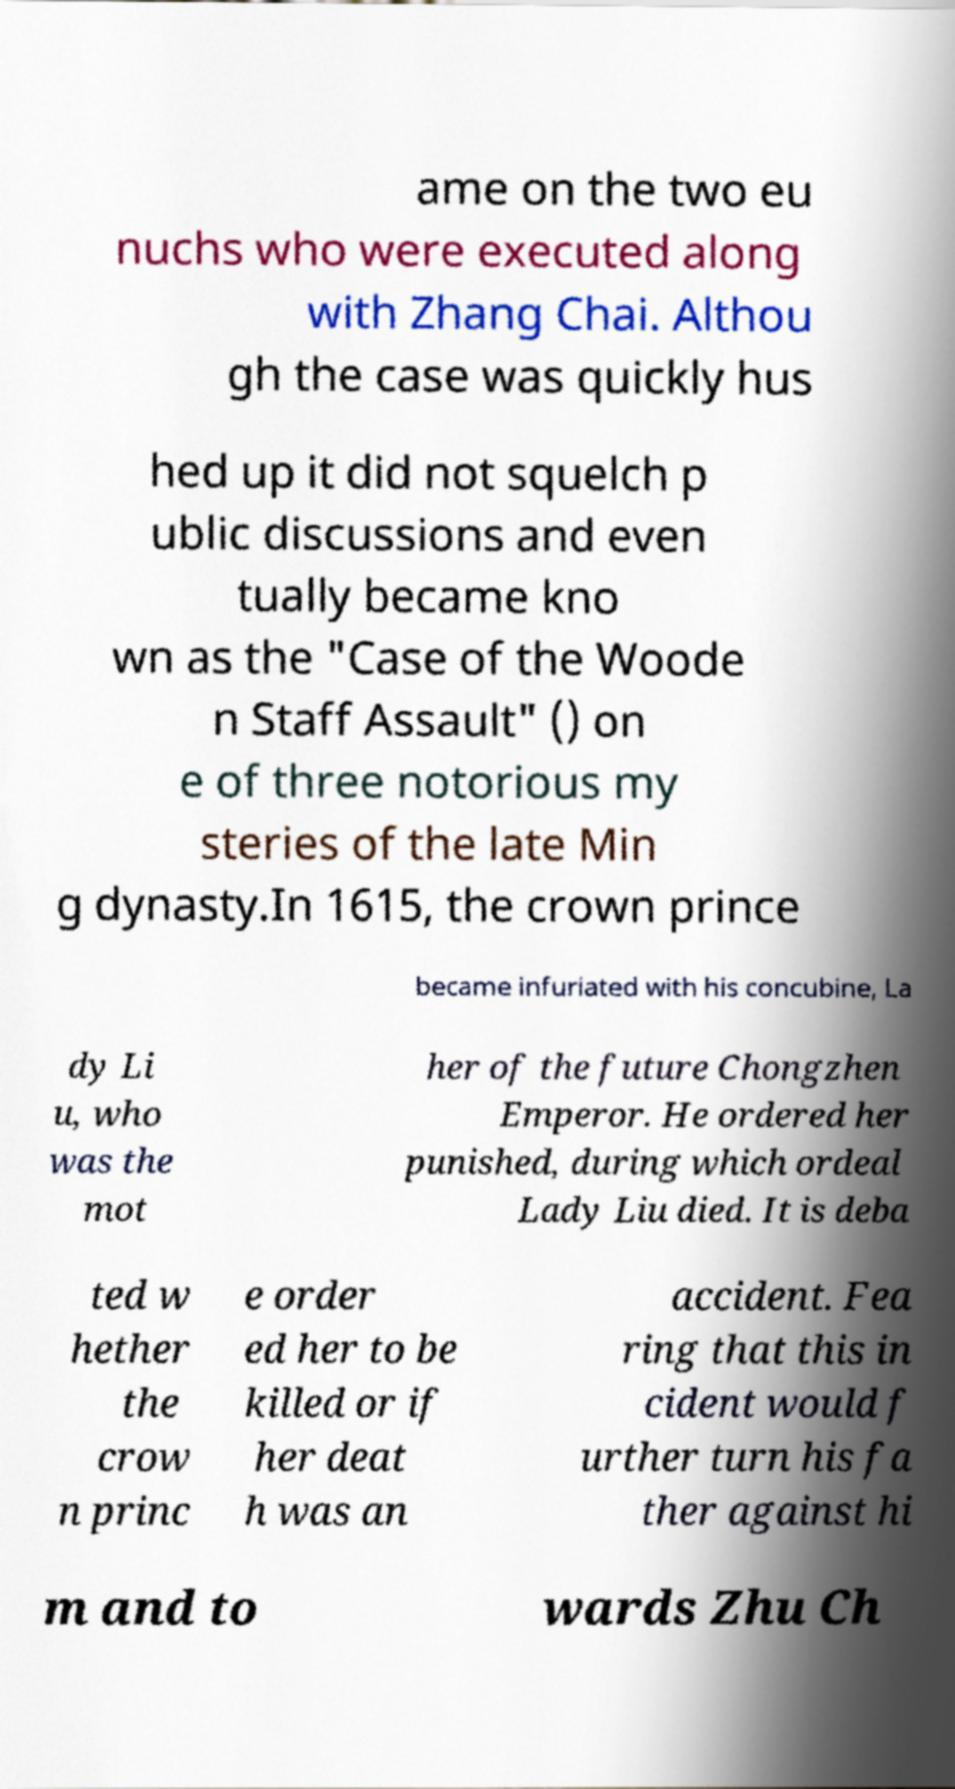There's text embedded in this image that I need extracted. Can you transcribe it verbatim? ame on the two eu nuchs who were executed along with Zhang Chai. Althou gh the case was quickly hus hed up it did not squelch p ublic discussions and even tually became kno wn as the "Case of the Woode n Staff Assault" () on e of three notorious my steries of the late Min g dynasty.In 1615, the crown prince became infuriated with his concubine, La dy Li u, who was the mot her of the future Chongzhen Emperor. He ordered her punished, during which ordeal Lady Liu died. It is deba ted w hether the crow n princ e order ed her to be killed or if her deat h was an accident. Fea ring that this in cident would f urther turn his fa ther against hi m and to wards Zhu Ch 